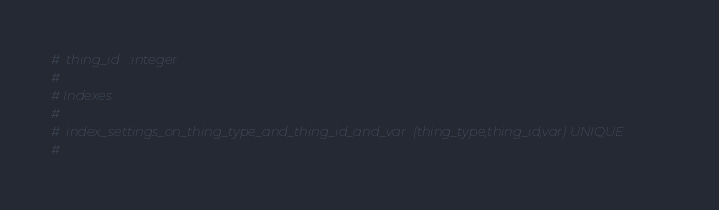<code> <loc_0><loc_0><loc_500><loc_500><_Ruby_>#  thing_id   :integer
#
# Indexes
#
#  index_settings_on_thing_type_and_thing_id_and_var  (thing_type,thing_id,var) UNIQUE
#
</code> 